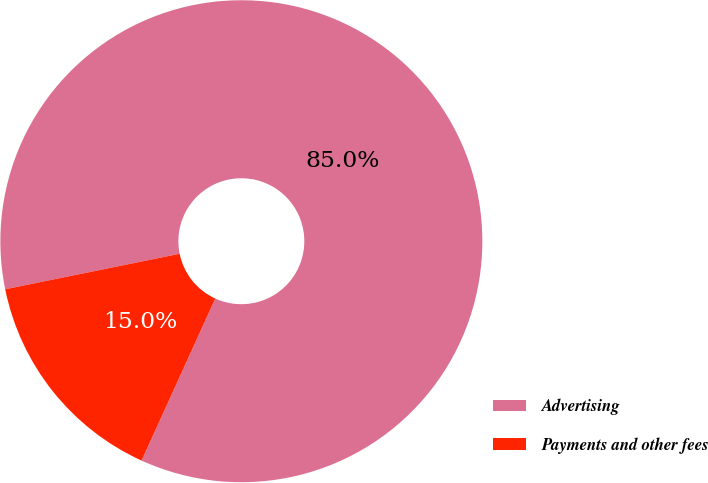Convert chart. <chart><loc_0><loc_0><loc_500><loc_500><pie_chart><fcel>Advertising<fcel>Payments and other fees<nl><fcel>84.99%<fcel>15.01%<nl></chart> 